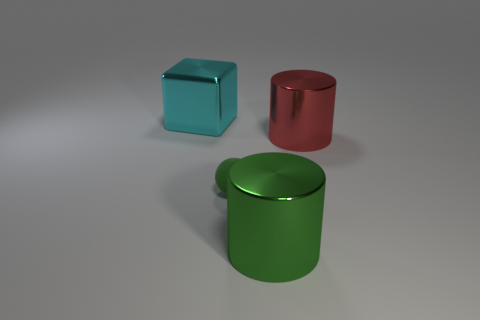There is a large metal thing that is the same color as the small thing; what shape is it?
Your answer should be compact. Cylinder. What number of cyan cubes are made of the same material as the green cylinder?
Make the answer very short. 1. The big shiny cube is what color?
Your response must be concise. Cyan. Is the shape of the big thing that is to the left of the big green thing the same as the big object in front of the small rubber sphere?
Offer a very short reply. No. What is the color of the cube that is on the left side of the small green matte object?
Your response must be concise. Cyan. Are there fewer large cyan metal objects that are in front of the small green sphere than small things that are in front of the block?
Ensure brevity in your answer.  Yes. What number of other objects are the same material as the red cylinder?
Keep it short and to the point. 2. Is the cyan object made of the same material as the big red thing?
Your answer should be very brief. Yes. How many other things are there of the same size as the cyan cube?
Ensure brevity in your answer.  2. There is a rubber thing that is left of the large shiny cylinder that is behind the small sphere; how big is it?
Your response must be concise. Small. 